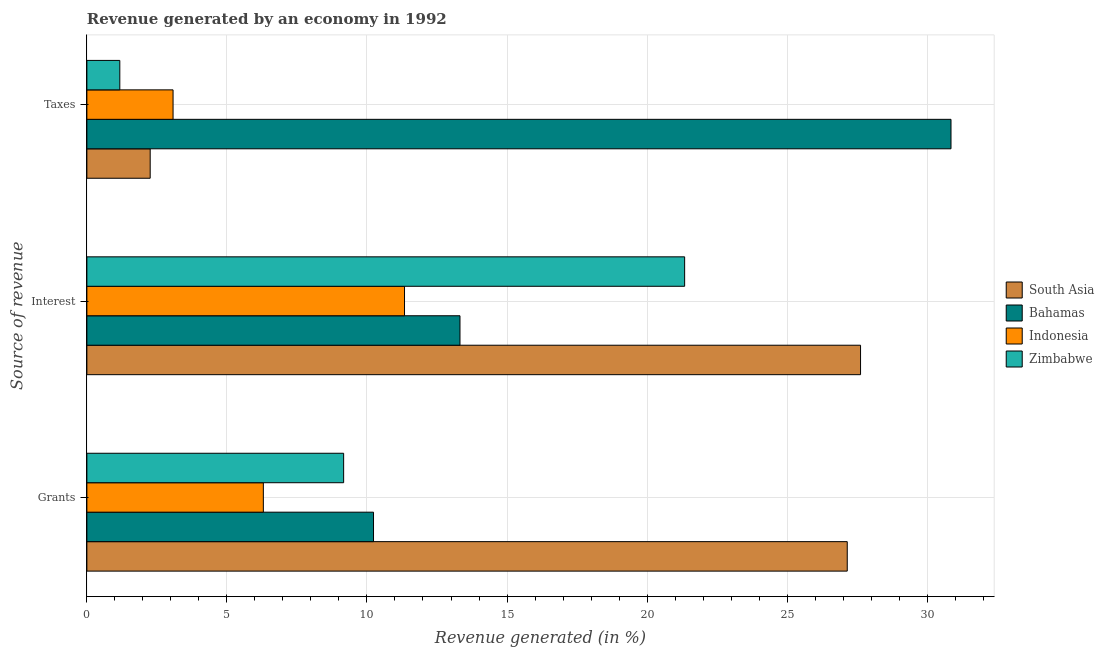How many different coloured bars are there?
Your answer should be compact. 4. How many groups of bars are there?
Your response must be concise. 3. How many bars are there on the 2nd tick from the top?
Offer a very short reply. 4. What is the label of the 3rd group of bars from the top?
Give a very brief answer. Grants. What is the percentage of revenue generated by taxes in Bahamas?
Your answer should be compact. 30.85. Across all countries, what is the maximum percentage of revenue generated by taxes?
Your response must be concise. 30.85. Across all countries, what is the minimum percentage of revenue generated by taxes?
Keep it short and to the point. 1.18. In which country was the percentage of revenue generated by interest maximum?
Offer a very short reply. South Asia. What is the total percentage of revenue generated by grants in the graph?
Give a very brief answer. 52.85. What is the difference between the percentage of revenue generated by taxes in South Asia and that in Indonesia?
Offer a terse response. -0.82. What is the difference between the percentage of revenue generated by taxes in Indonesia and the percentage of revenue generated by interest in South Asia?
Give a very brief answer. -24.54. What is the average percentage of revenue generated by taxes per country?
Make the answer very short. 9.34. What is the difference between the percentage of revenue generated by taxes and percentage of revenue generated by grants in Zimbabwe?
Your response must be concise. -7.99. In how many countries, is the percentage of revenue generated by taxes greater than 3 %?
Your response must be concise. 2. What is the ratio of the percentage of revenue generated by interest in Bahamas to that in Indonesia?
Offer a terse response. 1.17. Is the percentage of revenue generated by grants in South Asia less than that in Bahamas?
Give a very brief answer. No. What is the difference between the highest and the second highest percentage of revenue generated by grants?
Offer a terse response. 16.91. What is the difference between the highest and the lowest percentage of revenue generated by grants?
Keep it short and to the point. 20.85. Is the sum of the percentage of revenue generated by interest in Indonesia and Zimbabwe greater than the maximum percentage of revenue generated by taxes across all countries?
Give a very brief answer. Yes. What does the 2nd bar from the bottom in Interest represents?
Keep it short and to the point. Bahamas. How many bars are there?
Provide a succinct answer. 12. How many countries are there in the graph?
Offer a very short reply. 4. What is the difference between two consecutive major ticks on the X-axis?
Your response must be concise. 5. Are the values on the major ticks of X-axis written in scientific E-notation?
Provide a short and direct response. No. Does the graph contain any zero values?
Your response must be concise. No. Does the graph contain grids?
Provide a short and direct response. Yes. How many legend labels are there?
Your response must be concise. 4. How are the legend labels stacked?
Your response must be concise. Vertical. What is the title of the graph?
Your response must be concise. Revenue generated by an economy in 1992. Does "Finland" appear as one of the legend labels in the graph?
Make the answer very short. No. What is the label or title of the X-axis?
Your answer should be very brief. Revenue generated (in %). What is the label or title of the Y-axis?
Offer a very short reply. Source of revenue. What is the Revenue generated (in %) in South Asia in Grants?
Provide a succinct answer. 27.15. What is the Revenue generated (in %) of Bahamas in Grants?
Keep it short and to the point. 10.23. What is the Revenue generated (in %) in Indonesia in Grants?
Provide a succinct answer. 6.3. What is the Revenue generated (in %) in Zimbabwe in Grants?
Make the answer very short. 9.17. What is the Revenue generated (in %) in South Asia in Interest?
Provide a succinct answer. 27.62. What is the Revenue generated (in %) in Bahamas in Interest?
Your answer should be very brief. 13.32. What is the Revenue generated (in %) in Indonesia in Interest?
Keep it short and to the point. 11.34. What is the Revenue generated (in %) in Zimbabwe in Interest?
Offer a very short reply. 21.34. What is the Revenue generated (in %) of South Asia in Taxes?
Your response must be concise. 2.26. What is the Revenue generated (in %) in Bahamas in Taxes?
Your response must be concise. 30.85. What is the Revenue generated (in %) of Indonesia in Taxes?
Your response must be concise. 3.08. What is the Revenue generated (in %) of Zimbabwe in Taxes?
Provide a succinct answer. 1.18. Across all Source of revenue, what is the maximum Revenue generated (in %) in South Asia?
Keep it short and to the point. 27.62. Across all Source of revenue, what is the maximum Revenue generated (in %) in Bahamas?
Your answer should be compact. 30.85. Across all Source of revenue, what is the maximum Revenue generated (in %) in Indonesia?
Your response must be concise. 11.34. Across all Source of revenue, what is the maximum Revenue generated (in %) of Zimbabwe?
Ensure brevity in your answer.  21.34. Across all Source of revenue, what is the minimum Revenue generated (in %) in South Asia?
Provide a succinct answer. 2.26. Across all Source of revenue, what is the minimum Revenue generated (in %) in Bahamas?
Provide a short and direct response. 10.23. Across all Source of revenue, what is the minimum Revenue generated (in %) in Indonesia?
Provide a short and direct response. 3.08. Across all Source of revenue, what is the minimum Revenue generated (in %) of Zimbabwe?
Offer a terse response. 1.18. What is the total Revenue generated (in %) of South Asia in the graph?
Your response must be concise. 57.03. What is the total Revenue generated (in %) in Bahamas in the graph?
Provide a short and direct response. 54.41. What is the total Revenue generated (in %) of Indonesia in the graph?
Your answer should be very brief. 20.72. What is the total Revenue generated (in %) of Zimbabwe in the graph?
Offer a terse response. 31.68. What is the difference between the Revenue generated (in %) of South Asia in Grants and that in Interest?
Ensure brevity in your answer.  -0.47. What is the difference between the Revenue generated (in %) in Bahamas in Grants and that in Interest?
Provide a short and direct response. -3.09. What is the difference between the Revenue generated (in %) in Indonesia in Grants and that in Interest?
Provide a succinct answer. -5.04. What is the difference between the Revenue generated (in %) of Zimbabwe in Grants and that in Interest?
Give a very brief answer. -12.17. What is the difference between the Revenue generated (in %) of South Asia in Grants and that in Taxes?
Your answer should be compact. 24.89. What is the difference between the Revenue generated (in %) in Bahamas in Grants and that in Taxes?
Provide a succinct answer. -20.62. What is the difference between the Revenue generated (in %) of Indonesia in Grants and that in Taxes?
Your answer should be very brief. 3.22. What is the difference between the Revenue generated (in %) in Zimbabwe in Grants and that in Taxes?
Ensure brevity in your answer.  7.99. What is the difference between the Revenue generated (in %) in South Asia in Interest and that in Taxes?
Provide a short and direct response. 25.36. What is the difference between the Revenue generated (in %) in Bahamas in Interest and that in Taxes?
Give a very brief answer. -17.53. What is the difference between the Revenue generated (in %) in Indonesia in Interest and that in Taxes?
Make the answer very short. 8.26. What is the difference between the Revenue generated (in %) in Zimbabwe in Interest and that in Taxes?
Provide a short and direct response. 20.17. What is the difference between the Revenue generated (in %) in South Asia in Grants and the Revenue generated (in %) in Bahamas in Interest?
Keep it short and to the point. 13.83. What is the difference between the Revenue generated (in %) of South Asia in Grants and the Revenue generated (in %) of Indonesia in Interest?
Make the answer very short. 15.81. What is the difference between the Revenue generated (in %) of South Asia in Grants and the Revenue generated (in %) of Zimbabwe in Interest?
Your answer should be very brief. 5.81. What is the difference between the Revenue generated (in %) of Bahamas in Grants and the Revenue generated (in %) of Indonesia in Interest?
Give a very brief answer. -1.11. What is the difference between the Revenue generated (in %) of Bahamas in Grants and the Revenue generated (in %) of Zimbabwe in Interest?
Provide a succinct answer. -11.11. What is the difference between the Revenue generated (in %) in Indonesia in Grants and the Revenue generated (in %) in Zimbabwe in Interest?
Offer a very short reply. -15.04. What is the difference between the Revenue generated (in %) of South Asia in Grants and the Revenue generated (in %) of Bahamas in Taxes?
Provide a succinct answer. -3.7. What is the difference between the Revenue generated (in %) in South Asia in Grants and the Revenue generated (in %) in Indonesia in Taxes?
Offer a terse response. 24.07. What is the difference between the Revenue generated (in %) of South Asia in Grants and the Revenue generated (in %) of Zimbabwe in Taxes?
Provide a succinct answer. 25.97. What is the difference between the Revenue generated (in %) of Bahamas in Grants and the Revenue generated (in %) of Indonesia in Taxes?
Your answer should be compact. 7.16. What is the difference between the Revenue generated (in %) of Bahamas in Grants and the Revenue generated (in %) of Zimbabwe in Taxes?
Your answer should be compact. 9.06. What is the difference between the Revenue generated (in %) in Indonesia in Grants and the Revenue generated (in %) in Zimbabwe in Taxes?
Give a very brief answer. 5.12. What is the difference between the Revenue generated (in %) of South Asia in Interest and the Revenue generated (in %) of Bahamas in Taxes?
Provide a succinct answer. -3.23. What is the difference between the Revenue generated (in %) of South Asia in Interest and the Revenue generated (in %) of Indonesia in Taxes?
Make the answer very short. 24.54. What is the difference between the Revenue generated (in %) of South Asia in Interest and the Revenue generated (in %) of Zimbabwe in Taxes?
Keep it short and to the point. 26.45. What is the difference between the Revenue generated (in %) of Bahamas in Interest and the Revenue generated (in %) of Indonesia in Taxes?
Your response must be concise. 10.24. What is the difference between the Revenue generated (in %) in Bahamas in Interest and the Revenue generated (in %) in Zimbabwe in Taxes?
Keep it short and to the point. 12.15. What is the difference between the Revenue generated (in %) of Indonesia in Interest and the Revenue generated (in %) of Zimbabwe in Taxes?
Keep it short and to the point. 10.16. What is the average Revenue generated (in %) of South Asia per Source of revenue?
Your response must be concise. 19.01. What is the average Revenue generated (in %) in Bahamas per Source of revenue?
Your answer should be compact. 18.14. What is the average Revenue generated (in %) in Indonesia per Source of revenue?
Ensure brevity in your answer.  6.91. What is the average Revenue generated (in %) of Zimbabwe per Source of revenue?
Provide a succinct answer. 10.56. What is the difference between the Revenue generated (in %) in South Asia and Revenue generated (in %) in Bahamas in Grants?
Provide a succinct answer. 16.91. What is the difference between the Revenue generated (in %) in South Asia and Revenue generated (in %) in Indonesia in Grants?
Your answer should be very brief. 20.85. What is the difference between the Revenue generated (in %) of South Asia and Revenue generated (in %) of Zimbabwe in Grants?
Provide a succinct answer. 17.98. What is the difference between the Revenue generated (in %) of Bahamas and Revenue generated (in %) of Indonesia in Grants?
Your answer should be very brief. 3.93. What is the difference between the Revenue generated (in %) of Bahamas and Revenue generated (in %) of Zimbabwe in Grants?
Your response must be concise. 1.07. What is the difference between the Revenue generated (in %) in Indonesia and Revenue generated (in %) in Zimbabwe in Grants?
Offer a terse response. -2.87. What is the difference between the Revenue generated (in %) of South Asia and Revenue generated (in %) of Bahamas in Interest?
Give a very brief answer. 14.3. What is the difference between the Revenue generated (in %) in South Asia and Revenue generated (in %) in Indonesia in Interest?
Provide a short and direct response. 16.28. What is the difference between the Revenue generated (in %) in South Asia and Revenue generated (in %) in Zimbabwe in Interest?
Your answer should be compact. 6.28. What is the difference between the Revenue generated (in %) in Bahamas and Revenue generated (in %) in Indonesia in Interest?
Provide a short and direct response. 1.98. What is the difference between the Revenue generated (in %) in Bahamas and Revenue generated (in %) in Zimbabwe in Interest?
Give a very brief answer. -8.02. What is the difference between the Revenue generated (in %) of Indonesia and Revenue generated (in %) of Zimbabwe in Interest?
Ensure brevity in your answer.  -10. What is the difference between the Revenue generated (in %) in South Asia and Revenue generated (in %) in Bahamas in Taxes?
Provide a short and direct response. -28.59. What is the difference between the Revenue generated (in %) of South Asia and Revenue generated (in %) of Indonesia in Taxes?
Provide a succinct answer. -0.82. What is the difference between the Revenue generated (in %) of South Asia and Revenue generated (in %) of Zimbabwe in Taxes?
Provide a succinct answer. 1.08. What is the difference between the Revenue generated (in %) in Bahamas and Revenue generated (in %) in Indonesia in Taxes?
Your response must be concise. 27.77. What is the difference between the Revenue generated (in %) of Bahamas and Revenue generated (in %) of Zimbabwe in Taxes?
Make the answer very short. 29.68. What is the difference between the Revenue generated (in %) of Indonesia and Revenue generated (in %) of Zimbabwe in Taxes?
Your response must be concise. 1.9. What is the ratio of the Revenue generated (in %) of South Asia in Grants to that in Interest?
Your response must be concise. 0.98. What is the ratio of the Revenue generated (in %) of Bahamas in Grants to that in Interest?
Your answer should be compact. 0.77. What is the ratio of the Revenue generated (in %) in Indonesia in Grants to that in Interest?
Provide a short and direct response. 0.56. What is the ratio of the Revenue generated (in %) in Zimbabwe in Grants to that in Interest?
Provide a short and direct response. 0.43. What is the ratio of the Revenue generated (in %) of South Asia in Grants to that in Taxes?
Offer a terse response. 12.01. What is the ratio of the Revenue generated (in %) of Bahamas in Grants to that in Taxes?
Ensure brevity in your answer.  0.33. What is the ratio of the Revenue generated (in %) of Indonesia in Grants to that in Taxes?
Offer a terse response. 2.05. What is the ratio of the Revenue generated (in %) of Zimbabwe in Grants to that in Taxes?
Your answer should be compact. 7.8. What is the ratio of the Revenue generated (in %) of South Asia in Interest to that in Taxes?
Offer a terse response. 12.22. What is the ratio of the Revenue generated (in %) of Bahamas in Interest to that in Taxes?
Ensure brevity in your answer.  0.43. What is the ratio of the Revenue generated (in %) of Indonesia in Interest to that in Taxes?
Provide a short and direct response. 3.69. What is the ratio of the Revenue generated (in %) in Zimbabwe in Interest to that in Taxes?
Provide a succinct answer. 18.15. What is the difference between the highest and the second highest Revenue generated (in %) in South Asia?
Give a very brief answer. 0.47. What is the difference between the highest and the second highest Revenue generated (in %) of Bahamas?
Your response must be concise. 17.53. What is the difference between the highest and the second highest Revenue generated (in %) in Indonesia?
Provide a short and direct response. 5.04. What is the difference between the highest and the second highest Revenue generated (in %) in Zimbabwe?
Provide a succinct answer. 12.17. What is the difference between the highest and the lowest Revenue generated (in %) of South Asia?
Offer a terse response. 25.36. What is the difference between the highest and the lowest Revenue generated (in %) of Bahamas?
Make the answer very short. 20.62. What is the difference between the highest and the lowest Revenue generated (in %) of Indonesia?
Keep it short and to the point. 8.26. What is the difference between the highest and the lowest Revenue generated (in %) in Zimbabwe?
Provide a short and direct response. 20.17. 